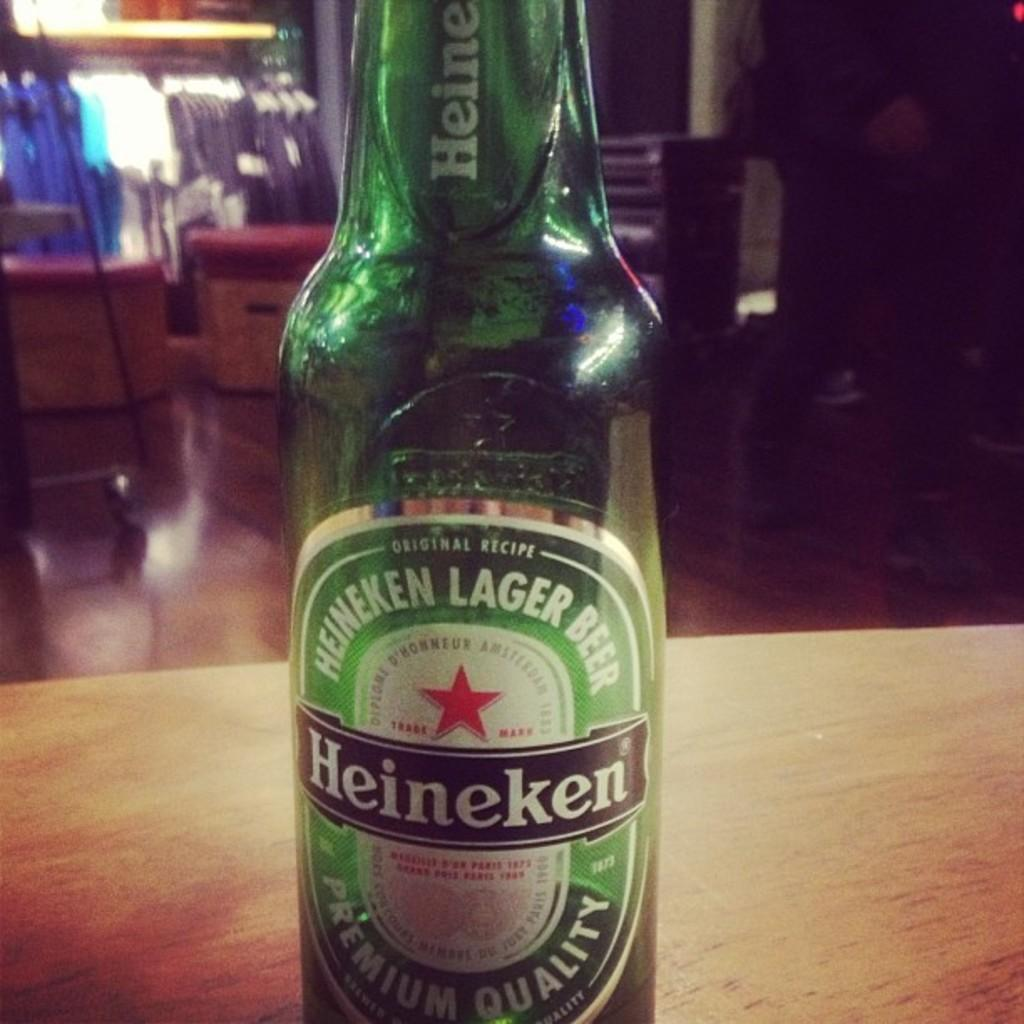<image>
Share a concise interpretation of the image provided. An green empty bottle with a Heineken beer label. 